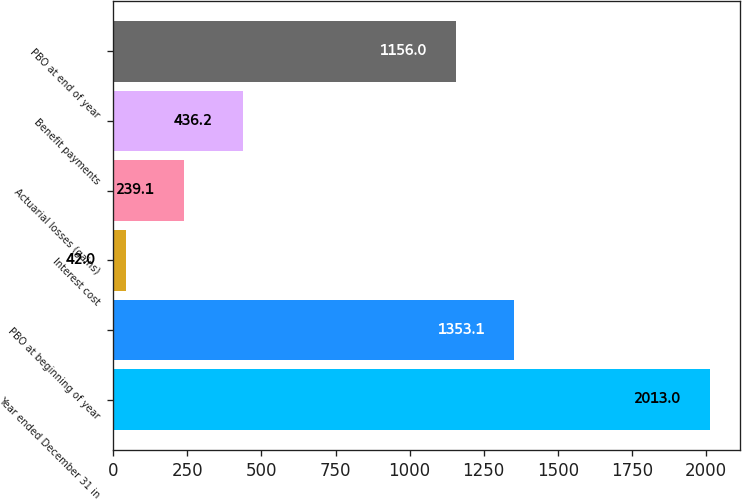<chart> <loc_0><loc_0><loc_500><loc_500><bar_chart><fcel>Year ended December 31 in<fcel>PBO at beginning of year<fcel>Interest cost<fcel>Actuarial losses (gains)<fcel>Benefit payments<fcel>PBO at end of year<nl><fcel>2013<fcel>1353.1<fcel>42<fcel>239.1<fcel>436.2<fcel>1156<nl></chart> 